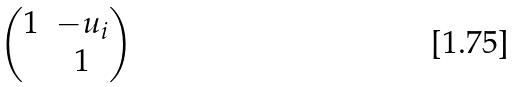<formula> <loc_0><loc_0><loc_500><loc_500>\begin{pmatrix} 1 & - u _ { i } \\ & 1 \end{pmatrix}</formula> 